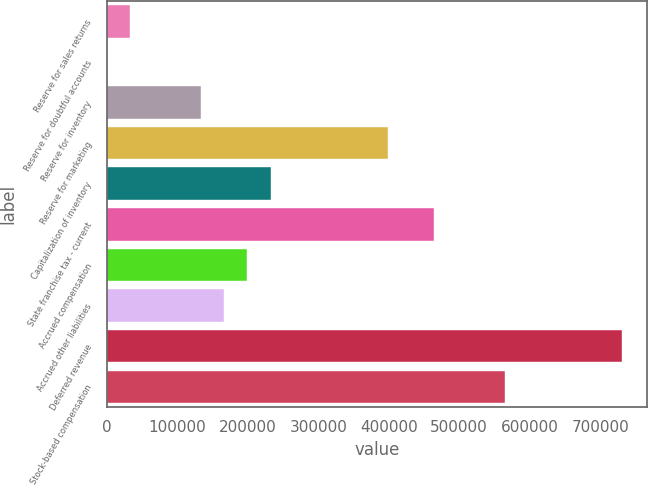<chart> <loc_0><loc_0><loc_500><loc_500><bar_chart><fcel>Reserve for sales returns<fcel>Reserve for doubtful accounts<fcel>Reserve for inventory<fcel>Reserve for marketing<fcel>Capitalization of inventory<fcel>State franchise tax - current<fcel>Accrued compensation<fcel>Accrued other liabilities<fcel>Deferred revenue<fcel>Stock-based compensation<nl><fcel>33220.3<fcel>18<fcel>132827<fcel>398446<fcel>232434<fcel>464850<fcel>199232<fcel>166030<fcel>730469<fcel>564457<nl></chart> 